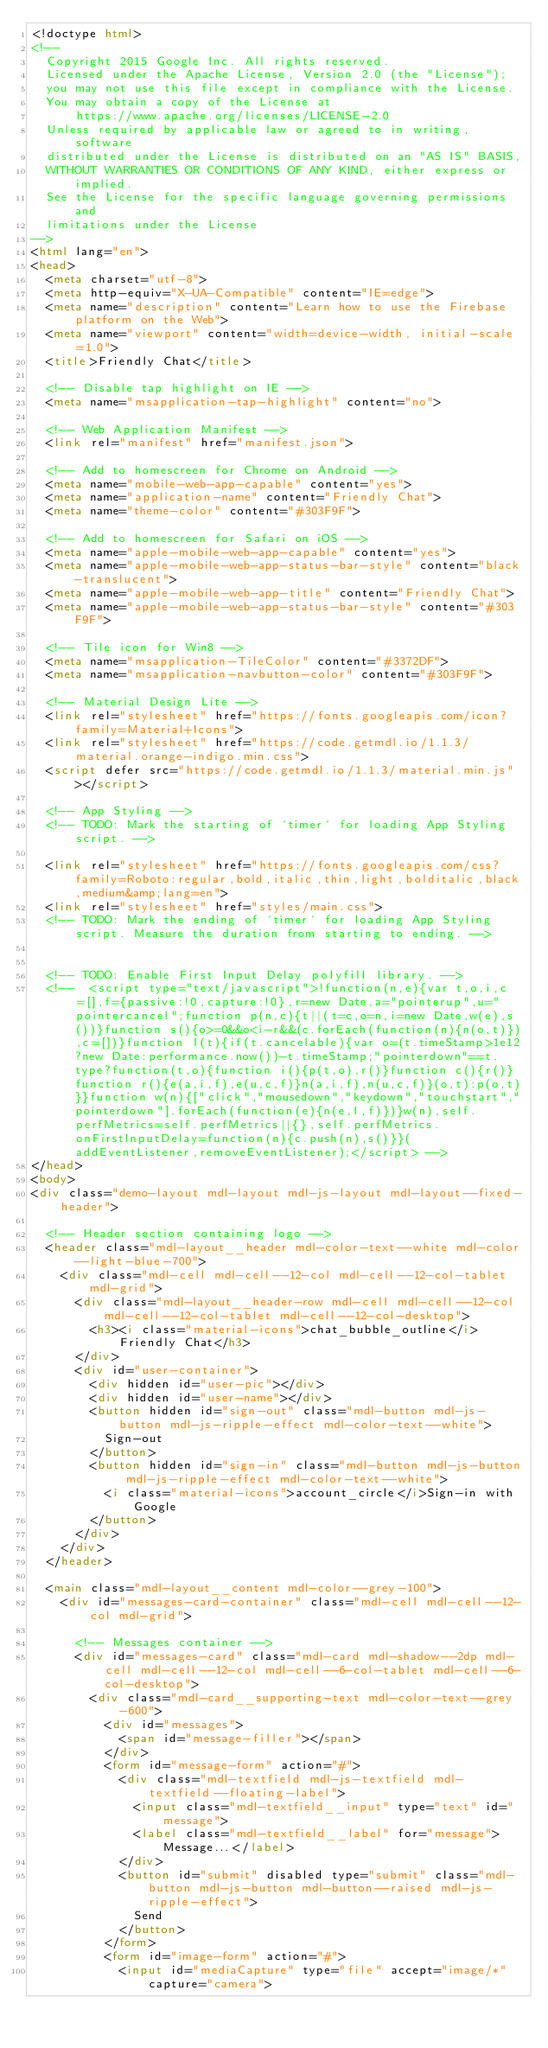Convert code to text. <code><loc_0><loc_0><loc_500><loc_500><_HTML_><!doctype html>
<!--
  Copyright 2015 Google Inc. All rights reserved.
  Licensed under the Apache License, Version 2.0 (the "License");
  you may not use this file except in compliance with the License.
  You may obtain a copy of the License at
      https://www.apache.org/licenses/LICENSE-2.0
  Unless required by applicable law or agreed to in writing, software
  distributed under the License is distributed on an "AS IS" BASIS,
  WITHOUT WARRANTIES OR CONDITIONS OF ANY KIND, either express or implied.
  See the License for the specific language governing permissions and
  limitations under the License
-->
<html lang="en">
<head>
  <meta charset="utf-8">
  <meta http-equiv="X-UA-Compatible" content="IE=edge">
  <meta name="description" content="Learn how to use the Firebase platform on the Web">
  <meta name="viewport" content="width=device-width, initial-scale=1.0">
  <title>Friendly Chat</title>

  <!-- Disable tap highlight on IE -->
  <meta name="msapplication-tap-highlight" content="no">

  <!-- Web Application Manifest -->
  <link rel="manifest" href="manifest.json">

  <!-- Add to homescreen for Chrome on Android -->
  <meta name="mobile-web-app-capable" content="yes">
  <meta name="application-name" content="Friendly Chat">
  <meta name="theme-color" content="#303F9F">

  <!-- Add to homescreen for Safari on iOS -->
  <meta name="apple-mobile-web-app-capable" content="yes">
  <meta name="apple-mobile-web-app-status-bar-style" content="black-translucent">
  <meta name="apple-mobile-web-app-title" content="Friendly Chat">
  <meta name="apple-mobile-web-app-status-bar-style" content="#303F9F">

  <!-- Tile icon for Win8 -->
  <meta name="msapplication-TileColor" content="#3372DF">
  <meta name="msapplication-navbutton-color" content="#303F9F">

  <!-- Material Design Lite -->
  <link rel="stylesheet" href="https://fonts.googleapis.com/icon?family=Material+Icons">
  <link rel="stylesheet" href="https://code.getmdl.io/1.1.3/material.orange-indigo.min.css">
  <script defer src="https://code.getmdl.io/1.1.3/material.min.js"></script>

  <!-- App Styling -->
  <!-- TODO: Mark the starting of `timer` for loading App Styling script. -->

  <link rel="stylesheet" href="https://fonts.googleapis.com/css?family=Roboto:regular,bold,italic,thin,light,bolditalic,black,medium&amp;lang=en">
  <link rel="stylesheet" href="styles/main.css">
  <!-- TODO: Mark the ending of `timer` for loading App Styling script. Measure the duration from starting to ending. -->


  <!-- TODO: Enable First Input Delay polyfill library. -->
  <!--  <script type="text/javascript">!function(n,e){var t,o,i,c=[],f={passive:!0,capture:!0},r=new Date,a="pointerup",u="pointercancel";function p(n,c){t||(t=c,o=n,i=new Date,w(e),s())}function s(){o>=0&&o<i-r&&(c.forEach(function(n){n(o,t)}),c=[])}function l(t){if(t.cancelable){var o=(t.timeStamp>1e12?new Date:performance.now())-t.timeStamp;"pointerdown"==t.type?function(t,o){function i(){p(t,o),r()}function c(){r()}function r(){e(a,i,f),e(u,c,f)}n(a,i,f),n(u,c,f)}(o,t):p(o,t)}}function w(n){["click","mousedown","keydown","touchstart","pointerdown"].forEach(function(e){n(e,l,f)})}w(n),self.perfMetrics=self.perfMetrics||{},self.perfMetrics.onFirstInputDelay=function(n){c.push(n),s()}}(addEventListener,removeEventListener);</script> -->
</head>
<body>
<div class="demo-layout mdl-layout mdl-js-layout mdl-layout--fixed-header">

  <!-- Header section containing logo -->
  <header class="mdl-layout__header mdl-color-text--white mdl-color--light-blue-700">
    <div class="mdl-cell mdl-cell--12-col mdl-cell--12-col-tablet mdl-grid">
      <div class="mdl-layout__header-row mdl-cell mdl-cell--12-col mdl-cell--12-col-tablet mdl-cell--12-col-desktop">
        <h3><i class="material-icons">chat_bubble_outline</i> Friendly Chat</h3>
      </div>
      <div id="user-container">
        <div hidden id="user-pic"></div>
        <div hidden id="user-name"></div>
        <button hidden id="sign-out" class="mdl-button mdl-js-button mdl-js-ripple-effect mdl-color-text--white">
          Sign-out
        </button>
        <button hidden id="sign-in" class="mdl-button mdl-js-button mdl-js-ripple-effect mdl-color-text--white">
          <i class="material-icons">account_circle</i>Sign-in with Google
        </button>
      </div>
    </div>
  </header>

  <main class="mdl-layout__content mdl-color--grey-100">
    <div id="messages-card-container" class="mdl-cell mdl-cell--12-col mdl-grid">

      <!-- Messages container -->
      <div id="messages-card" class="mdl-card mdl-shadow--2dp mdl-cell mdl-cell--12-col mdl-cell--6-col-tablet mdl-cell--6-col-desktop">
        <div class="mdl-card__supporting-text mdl-color-text--grey-600">
          <div id="messages">
            <span id="message-filler"></span>
          </div>
          <form id="message-form" action="#">
            <div class="mdl-textfield mdl-js-textfield mdl-textfield--floating-label">
              <input class="mdl-textfield__input" type="text" id="message">
              <label class="mdl-textfield__label" for="message">Message...</label>
            </div>
            <button id="submit" disabled type="submit" class="mdl-button mdl-js-button mdl-button--raised mdl-js-ripple-effect">
              Send
            </button>
          </form>
          <form id="image-form" action="#">
            <input id="mediaCapture" type="file" accept="image/*" capture="camera"></code> 